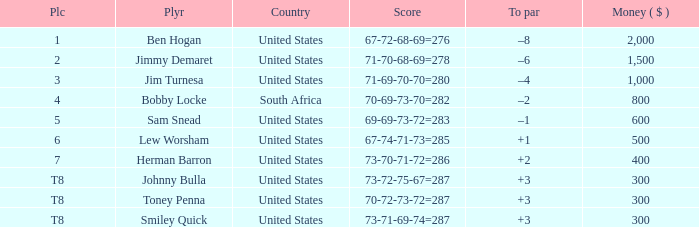What is the To par of the 4 Place Player? –2. 